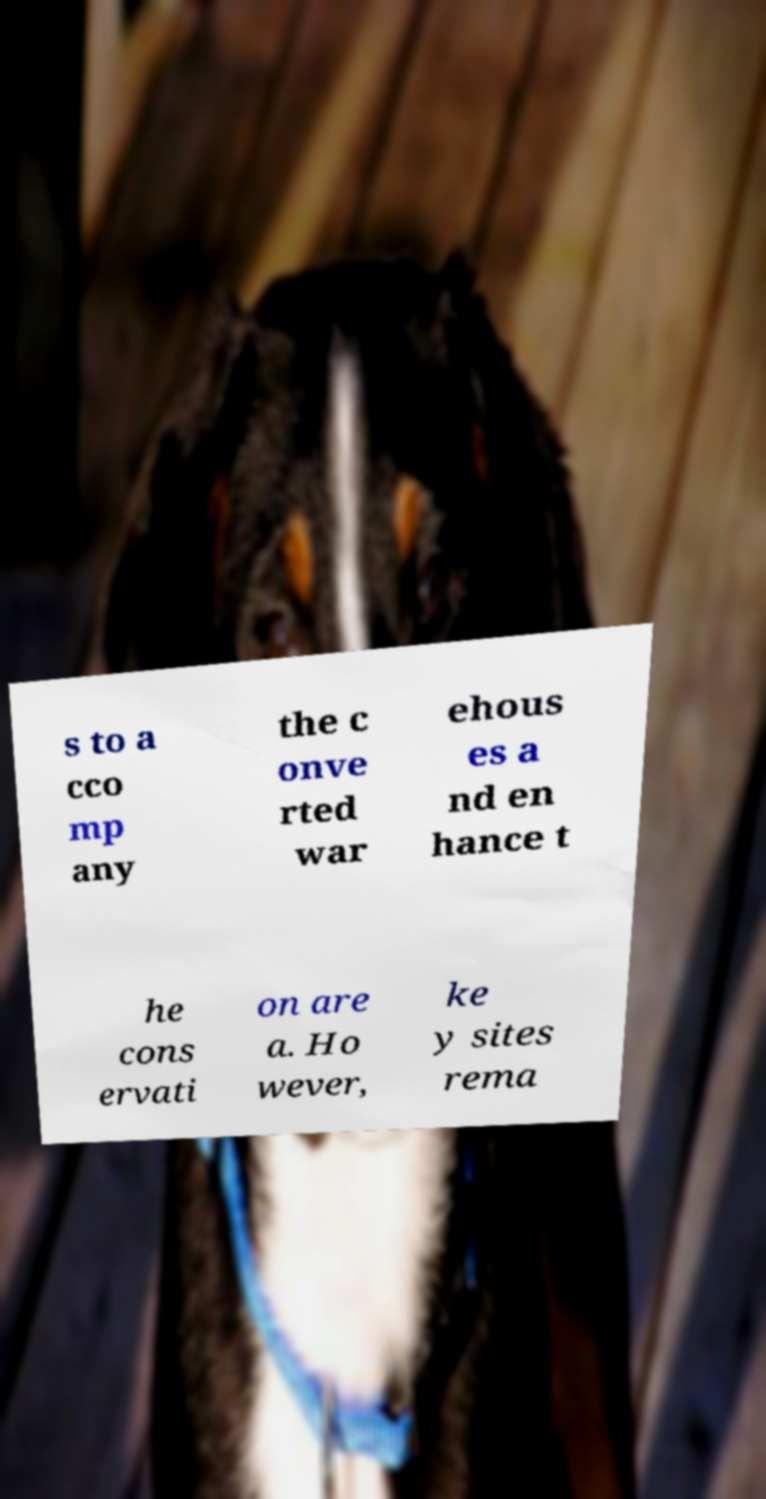Please read and relay the text visible in this image. What does it say? s to a cco mp any the c onve rted war ehous es a nd en hance t he cons ervati on are a. Ho wever, ke y sites rema 